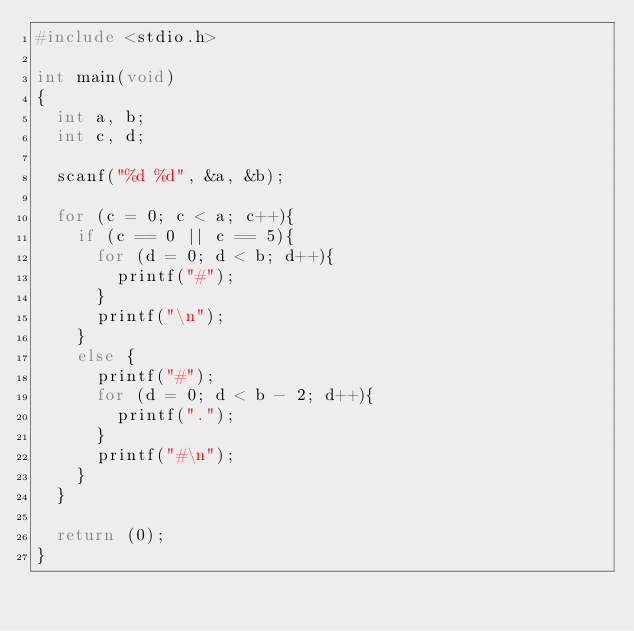<code> <loc_0><loc_0><loc_500><loc_500><_C_>#include <stdio.h>

int main(void)
{
	int a, b;
	int c, d;
	
	scanf("%d %d", &a, &b);
	
	for (c = 0; c < a; c++){
		if (c == 0 || c == 5){
			for (d = 0; d < b; d++){
				printf("#");
			}
			printf("\n");
		}
		else {
			printf("#");
			for (d = 0; d < b - 2; d++){
				printf(".");
			}	
			printf("#\n");
		}
	}
	
	return (0);
}</code> 